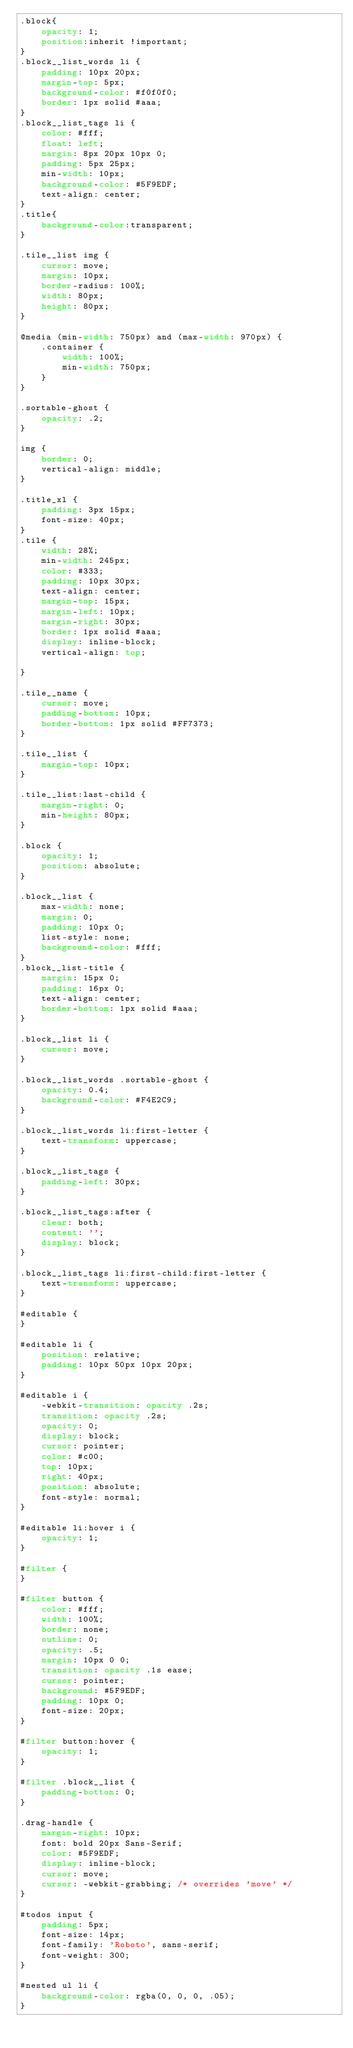Convert code to text. <code><loc_0><loc_0><loc_500><loc_500><_CSS_>.block{
    opacity: 1;
    position:inherit !important;
}
.block__list_words li {
    padding: 10px 20px;
    margin-top: 5px;
    background-color: #f0f0f0;
    border: 1px solid #aaa;
}
.block__list_tags li {
    color: #fff;
    float: left;
    margin: 8px 20px 10px 0;
    padding: 5px 25px;
    min-width: 10px;
    background-color: #5F9EDF;
    text-align: center;
}
.title{
    background-color:transparent;
}

.tile__list img {
    cursor: move;
    margin: 10px;
    border-radius: 100%;
    width: 80px;
    height: 80px;
}

@media (min-width: 750px) and (max-width: 970px) {
    .container {
        width: 100%;
        min-width: 750px;
    }
}

.sortable-ghost {
    opacity: .2;
}

img {
    border: 0;
    vertical-align: middle;
}

.title_xl {
    padding: 3px 15px;
    font-size: 40px;
}
.tile {
    width: 28%;
    min-width: 245px;
    color: #333;
    padding: 10px 30px;
    text-align: center;
    margin-top: 15px;
    margin-left: 10px;
    margin-right: 30px;
    border: 1px solid #aaa;
    display: inline-block;
    vertical-align: top;

}

.tile__name {
    cursor: move;
    padding-bottom: 10px;
    border-bottom: 1px solid #FF7373;
}

.tile__list {
    margin-top: 10px;
}

.tile__list:last-child {
    margin-right: 0;
    min-height: 80px;
}

.block {
    opacity: 1;
    position: absolute;
}

.block__list {
    max-width: none;
    margin: 0;
    padding: 10px 0;
    list-style: none;
    background-color: #fff;
}
.block__list-title {
    margin: 15px 0;
    padding: 16px 0;
    text-align: center;
    border-bottom: 1px solid #aaa;
}

.block__list li {
    cursor: move;
}

.block__list_words .sortable-ghost {
    opacity: 0.4;
    background-color: #F4E2C9;
}

.block__list_words li:first-letter {
    text-transform: uppercase;
}

.block__list_tags {
    padding-left: 30px;
}

.block__list_tags:after {
    clear: both;
    content: '';
    display: block;
}

.block__list_tags li:first-child:first-letter {
    text-transform: uppercase;
}

#editable {
}

#editable li {
    position: relative;
    padding: 10px 50px 10px 20px;
}

#editable i {
    -webkit-transition: opacity .2s;
    transition: opacity .2s;
    opacity: 0;
    display: block;
    cursor: pointer;
    color: #c00;
    top: 10px;
    right: 40px;
    position: absolute;
    font-style: normal;
}

#editable li:hover i {
    opacity: 1;
}

#filter {
}

#filter button {
    color: #fff;
    width: 100%;
    border: none;
    outline: 0;
    opacity: .5;
    margin: 10px 0 0;
    transition: opacity .1s ease;
    cursor: pointer;
    background: #5F9EDF;
    padding: 10px 0;
    font-size: 20px;
}

#filter button:hover {
    opacity: 1;
}

#filter .block__list {
    padding-bottom: 0;
}

.drag-handle {
    margin-right: 10px;
    font: bold 20px Sans-Serif;
    color: #5F9EDF;
    display: inline-block;
    cursor: move;
    cursor: -webkit-grabbing; /* overrides 'move' */
}

#todos input {
    padding: 5px;
    font-size: 14px;
    font-family: 'Roboto', sans-serif;
    font-weight: 300;
}

#nested ul li {
    background-color: rgba(0, 0, 0, .05);
}
</code> 